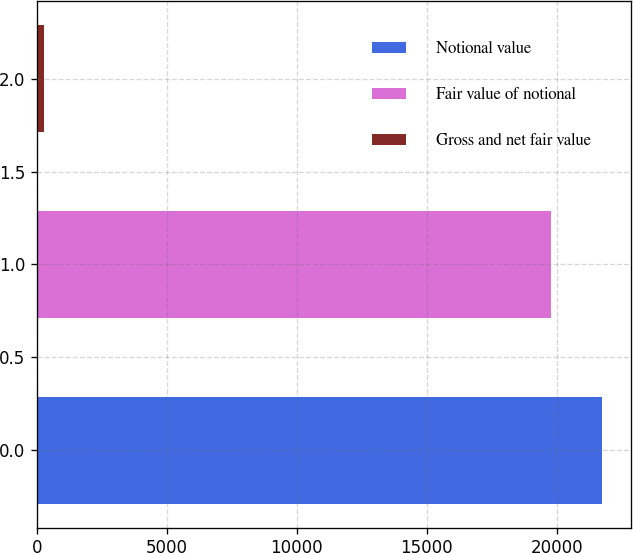Convert chart. <chart><loc_0><loc_0><loc_500><loc_500><bar_chart><fcel>Notional value<fcel>Fair value of notional<fcel>Gross and net fair value<nl><fcel>21754.7<fcel>19777<fcel>264<nl></chart> 